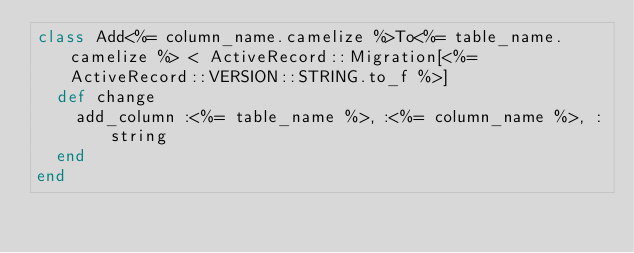Convert code to text. <code><loc_0><loc_0><loc_500><loc_500><_Ruby_>class Add<%= column_name.camelize %>To<%= table_name.camelize %> < ActiveRecord::Migration[<%=  ActiveRecord::VERSION::STRING.to_f %>]
  def change
    add_column :<%= table_name %>, :<%= column_name %>, :string
  end
end
</code> 